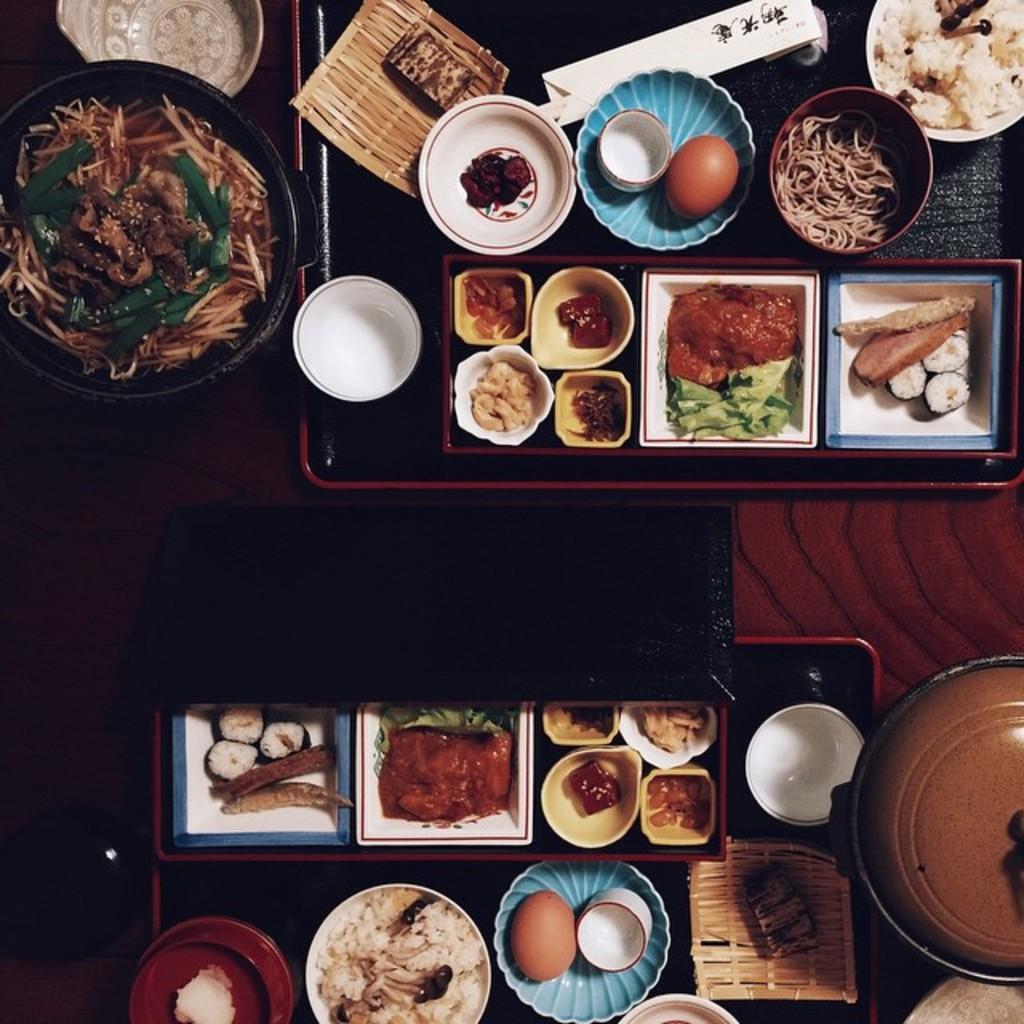Describe this image in one or two sentences. In this image I can see few food items on the table. 